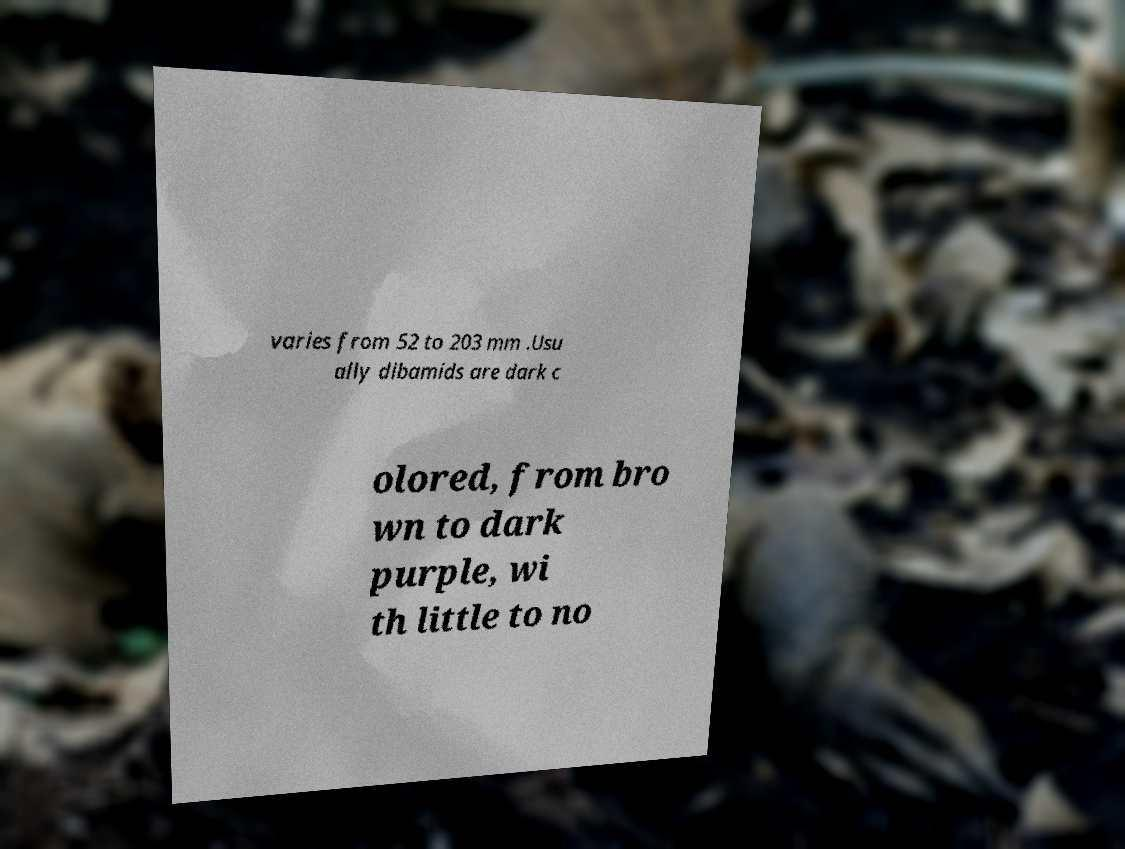Can you accurately transcribe the text from the provided image for me? varies from 52 to 203 mm .Usu ally dibamids are dark c olored, from bro wn to dark purple, wi th little to no 